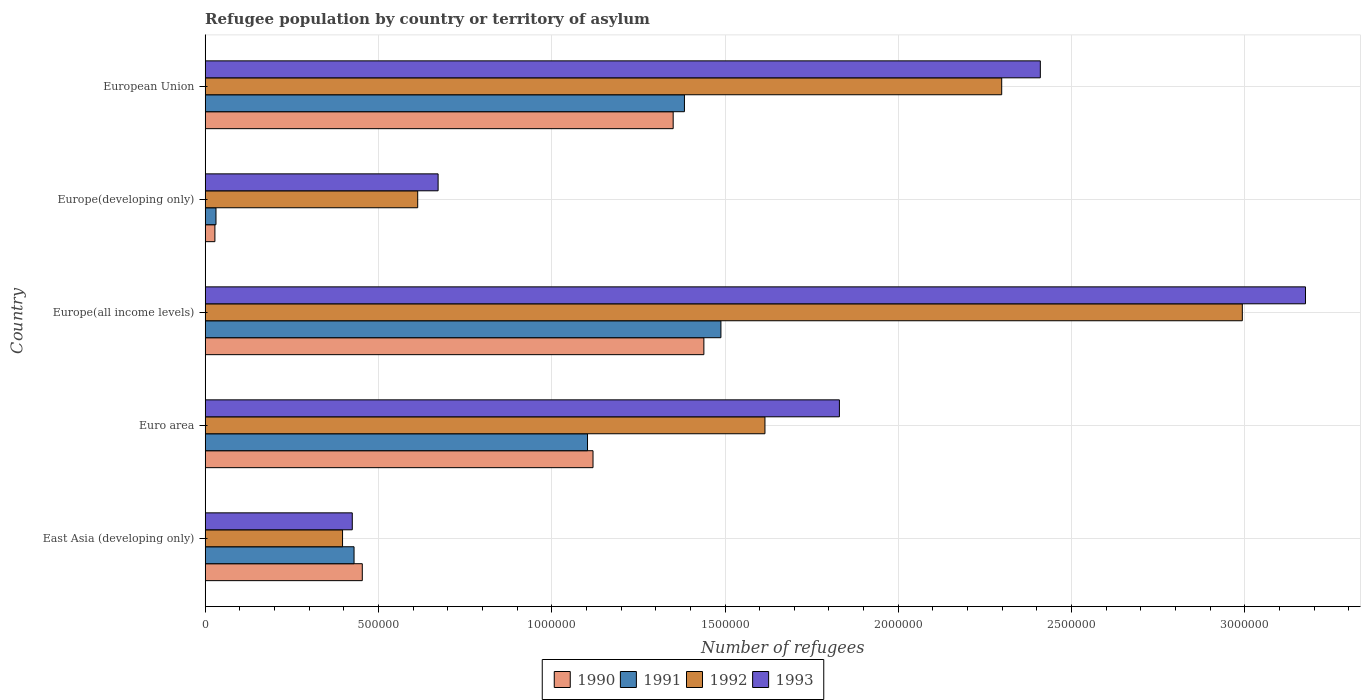How many different coloured bars are there?
Provide a short and direct response. 4. Are the number of bars per tick equal to the number of legend labels?
Provide a succinct answer. Yes. How many bars are there on the 5th tick from the top?
Give a very brief answer. 4. How many bars are there on the 5th tick from the bottom?
Your answer should be very brief. 4. What is the label of the 4th group of bars from the top?
Provide a succinct answer. Euro area. In how many cases, is the number of bars for a given country not equal to the number of legend labels?
Make the answer very short. 0. What is the number of refugees in 1993 in Europe(all income levels)?
Give a very brief answer. 3.18e+06. Across all countries, what is the maximum number of refugees in 1992?
Provide a short and direct response. 2.99e+06. Across all countries, what is the minimum number of refugees in 1990?
Provide a short and direct response. 2.80e+04. In which country was the number of refugees in 1992 maximum?
Your answer should be very brief. Europe(all income levels). In which country was the number of refugees in 1992 minimum?
Your answer should be compact. East Asia (developing only). What is the total number of refugees in 1992 in the graph?
Give a very brief answer. 7.92e+06. What is the difference between the number of refugees in 1991 in Europe(developing only) and that in European Union?
Your response must be concise. -1.35e+06. What is the difference between the number of refugees in 1990 in Europe(developing only) and the number of refugees in 1991 in European Union?
Make the answer very short. -1.35e+06. What is the average number of refugees in 1990 per country?
Your answer should be compact. 8.78e+05. What is the difference between the number of refugees in 1991 and number of refugees in 1990 in Europe(developing only)?
Your response must be concise. 3113. In how many countries, is the number of refugees in 1991 greater than 2700000 ?
Your response must be concise. 0. What is the ratio of the number of refugees in 1992 in Euro area to that in Europe(developing only)?
Provide a short and direct response. 2.63. What is the difference between the highest and the second highest number of refugees in 1991?
Your answer should be very brief. 1.05e+05. What is the difference between the highest and the lowest number of refugees in 1992?
Provide a short and direct response. 2.60e+06. Is the sum of the number of refugees in 1993 in East Asia (developing only) and Euro area greater than the maximum number of refugees in 1991 across all countries?
Make the answer very short. Yes. What does the 4th bar from the top in Euro area represents?
Provide a short and direct response. 1990. What does the 1st bar from the bottom in Euro area represents?
Make the answer very short. 1990. Is it the case that in every country, the sum of the number of refugees in 1993 and number of refugees in 1992 is greater than the number of refugees in 1991?
Your answer should be compact. Yes. Does the graph contain grids?
Provide a short and direct response. Yes. What is the title of the graph?
Make the answer very short. Refugee population by country or territory of asylum. Does "1962" appear as one of the legend labels in the graph?
Give a very brief answer. No. What is the label or title of the X-axis?
Give a very brief answer. Number of refugees. What is the Number of refugees in 1990 in East Asia (developing only)?
Provide a succinct answer. 4.53e+05. What is the Number of refugees of 1991 in East Asia (developing only)?
Offer a terse response. 4.30e+05. What is the Number of refugees of 1992 in East Asia (developing only)?
Make the answer very short. 3.96e+05. What is the Number of refugees in 1993 in East Asia (developing only)?
Offer a very short reply. 4.24e+05. What is the Number of refugees of 1990 in Euro area?
Provide a succinct answer. 1.12e+06. What is the Number of refugees of 1991 in Euro area?
Your answer should be very brief. 1.10e+06. What is the Number of refugees in 1992 in Euro area?
Provide a succinct answer. 1.62e+06. What is the Number of refugees of 1993 in Euro area?
Offer a terse response. 1.83e+06. What is the Number of refugees of 1990 in Europe(all income levels)?
Offer a terse response. 1.44e+06. What is the Number of refugees of 1991 in Europe(all income levels)?
Ensure brevity in your answer.  1.49e+06. What is the Number of refugees of 1992 in Europe(all income levels)?
Make the answer very short. 2.99e+06. What is the Number of refugees in 1993 in Europe(all income levels)?
Your answer should be very brief. 3.18e+06. What is the Number of refugees of 1990 in Europe(developing only)?
Your response must be concise. 2.80e+04. What is the Number of refugees of 1991 in Europe(developing only)?
Your answer should be very brief. 3.11e+04. What is the Number of refugees of 1992 in Europe(developing only)?
Offer a terse response. 6.13e+05. What is the Number of refugees in 1993 in Europe(developing only)?
Offer a very short reply. 6.72e+05. What is the Number of refugees of 1990 in European Union?
Provide a succinct answer. 1.35e+06. What is the Number of refugees of 1991 in European Union?
Offer a very short reply. 1.38e+06. What is the Number of refugees of 1992 in European Union?
Offer a terse response. 2.30e+06. What is the Number of refugees in 1993 in European Union?
Your answer should be very brief. 2.41e+06. Across all countries, what is the maximum Number of refugees in 1990?
Offer a terse response. 1.44e+06. Across all countries, what is the maximum Number of refugees in 1991?
Your answer should be compact. 1.49e+06. Across all countries, what is the maximum Number of refugees in 1992?
Make the answer very short. 2.99e+06. Across all countries, what is the maximum Number of refugees in 1993?
Your answer should be very brief. 3.18e+06. Across all countries, what is the minimum Number of refugees in 1990?
Provide a succinct answer. 2.80e+04. Across all countries, what is the minimum Number of refugees of 1991?
Your response must be concise. 3.11e+04. Across all countries, what is the minimum Number of refugees in 1992?
Make the answer very short. 3.96e+05. Across all countries, what is the minimum Number of refugees in 1993?
Ensure brevity in your answer.  4.24e+05. What is the total Number of refugees in 1990 in the graph?
Keep it short and to the point. 4.39e+06. What is the total Number of refugees in 1991 in the graph?
Ensure brevity in your answer.  4.44e+06. What is the total Number of refugees in 1992 in the graph?
Offer a terse response. 7.92e+06. What is the total Number of refugees of 1993 in the graph?
Your response must be concise. 8.51e+06. What is the difference between the Number of refugees of 1990 in East Asia (developing only) and that in Euro area?
Keep it short and to the point. -6.66e+05. What is the difference between the Number of refugees in 1991 in East Asia (developing only) and that in Euro area?
Provide a succinct answer. -6.74e+05. What is the difference between the Number of refugees of 1992 in East Asia (developing only) and that in Euro area?
Offer a terse response. -1.22e+06. What is the difference between the Number of refugees in 1993 in East Asia (developing only) and that in Euro area?
Your response must be concise. -1.41e+06. What is the difference between the Number of refugees of 1990 in East Asia (developing only) and that in Europe(all income levels)?
Your answer should be compact. -9.86e+05. What is the difference between the Number of refugees in 1991 in East Asia (developing only) and that in Europe(all income levels)?
Ensure brevity in your answer.  -1.06e+06. What is the difference between the Number of refugees in 1992 in East Asia (developing only) and that in Europe(all income levels)?
Provide a short and direct response. -2.60e+06. What is the difference between the Number of refugees in 1993 in East Asia (developing only) and that in Europe(all income levels)?
Ensure brevity in your answer.  -2.75e+06. What is the difference between the Number of refugees of 1990 in East Asia (developing only) and that in Europe(developing only)?
Offer a terse response. 4.25e+05. What is the difference between the Number of refugees in 1991 in East Asia (developing only) and that in Europe(developing only)?
Provide a succinct answer. 3.98e+05. What is the difference between the Number of refugees of 1992 in East Asia (developing only) and that in Europe(developing only)?
Your answer should be very brief. -2.17e+05. What is the difference between the Number of refugees in 1993 in East Asia (developing only) and that in Europe(developing only)?
Your response must be concise. -2.48e+05. What is the difference between the Number of refugees of 1990 in East Asia (developing only) and that in European Union?
Your response must be concise. -8.97e+05. What is the difference between the Number of refugees in 1991 in East Asia (developing only) and that in European Union?
Keep it short and to the point. -9.53e+05. What is the difference between the Number of refugees of 1992 in East Asia (developing only) and that in European Union?
Provide a succinct answer. -1.90e+06. What is the difference between the Number of refugees of 1993 in East Asia (developing only) and that in European Union?
Ensure brevity in your answer.  -1.99e+06. What is the difference between the Number of refugees of 1990 in Euro area and that in Europe(all income levels)?
Provide a short and direct response. -3.20e+05. What is the difference between the Number of refugees in 1991 in Euro area and that in Europe(all income levels)?
Provide a succinct answer. -3.85e+05. What is the difference between the Number of refugees of 1992 in Euro area and that in Europe(all income levels)?
Your answer should be very brief. -1.38e+06. What is the difference between the Number of refugees of 1993 in Euro area and that in Europe(all income levels)?
Offer a terse response. -1.34e+06. What is the difference between the Number of refugees in 1990 in Euro area and that in Europe(developing only)?
Your answer should be compact. 1.09e+06. What is the difference between the Number of refugees in 1991 in Euro area and that in Europe(developing only)?
Make the answer very short. 1.07e+06. What is the difference between the Number of refugees in 1992 in Euro area and that in Europe(developing only)?
Your answer should be compact. 1.00e+06. What is the difference between the Number of refugees of 1993 in Euro area and that in Europe(developing only)?
Make the answer very short. 1.16e+06. What is the difference between the Number of refugees in 1990 in Euro area and that in European Union?
Offer a terse response. -2.31e+05. What is the difference between the Number of refugees of 1991 in Euro area and that in European Union?
Make the answer very short. -2.80e+05. What is the difference between the Number of refugees of 1992 in Euro area and that in European Union?
Ensure brevity in your answer.  -6.83e+05. What is the difference between the Number of refugees of 1993 in Euro area and that in European Union?
Your answer should be very brief. -5.80e+05. What is the difference between the Number of refugees of 1990 in Europe(all income levels) and that in Europe(developing only)?
Give a very brief answer. 1.41e+06. What is the difference between the Number of refugees of 1991 in Europe(all income levels) and that in Europe(developing only)?
Offer a very short reply. 1.46e+06. What is the difference between the Number of refugees in 1992 in Europe(all income levels) and that in Europe(developing only)?
Give a very brief answer. 2.38e+06. What is the difference between the Number of refugees of 1993 in Europe(all income levels) and that in Europe(developing only)?
Provide a short and direct response. 2.50e+06. What is the difference between the Number of refugees in 1990 in Europe(all income levels) and that in European Union?
Keep it short and to the point. 8.86e+04. What is the difference between the Number of refugees in 1991 in Europe(all income levels) and that in European Union?
Keep it short and to the point. 1.05e+05. What is the difference between the Number of refugees in 1992 in Europe(all income levels) and that in European Union?
Your answer should be compact. 6.94e+05. What is the difference between the Number of refugees of 1993 in Europe(all income levels) and that in European Union?
Provide a short and direct response. 7.65e+05. What is the difference between the Number of refugees in 1990 in Europe(developing only) and that in European Union?
Your answer should be compact. -1.32e+06. What is the difference between the Number of refugees of 1991 in Europe(developing only) and that in European Union?
Provide a short and direct response. -1.35e+06. What is the difference between the Number of refugees in 1992 in Europe(developing only) and that in European Union?
Give a very brief answer. -1.69e+06. What is the difference between the Number of refugees in 1993 in Europe(developing only) and that in European Union?
Keep it short and to the point. -1.74e+06. What is the difference between the Number of refugees in 1990 in East Asia (developing only) and the Number of refugees in 1991 in Euro area?
Your answer should be very brief. -6.50e+05. What is the difference between the Number of refugees in 1990 in East Asia (developing only) and the Number of refugees in 1992 in Euro area?
Your response must be concise. -1.16e+06. What is the difference between the Number of refugees in 1990 in East Asia (developing only) and the Number of refugees in 1993 in Euro area?
Provide a short and direct response. -1.38e+06. What is the difference between the Number of refugees in 1991 in East Asia (developing only) and the Number of refugees in 1992 in Euro area?
Your answer should be compact. -1.19e+06. What is the difference between the Number of refugees of 1991 in East Asia (developing only) and the Number of refugees of 1993 in Euro area?
Ensure brevity in your answer.  -1.40e+06. What is the difference between the Number of refugees of 1992 in East Asia (developing only) and the Number of refugees of 1993 in Euro area?
Give a very brief answer. -1.43e+06. What is the difference between the Number of refugees of 1990 in East Asia (developing only) and the Number of refugees of 1991 in Europe(all income levels)?
Offer a terse response. -1.03e+06. What is the difference between the Number of refugees in 1990 in East Asia (developing only) and the Number of refugees in 1992 in Europe(all income levels)?
Provide a succinct answer. -2.54e+06. What is the difference between the Number of refugees of 1990 in East Asia (developing only) and the Number of refugees of 1993 in Europe(all income levels)?
Ensure brevity in your answer.  -2.72e+06. What is the difference between the Number of refugees of 1991 in East Asia (developing only) and the Number of refugees of 1992 in Europe(all income levels)?
Give a very brief answer. -2.56e+06. What is the difference between the Number of refugees in 1991 in East Asia (developing only) and the Number of refugees in 1993 in Europe(all income levels)?
Your answer should be compact. -2.75e+06. What is the difference between the Number of refugees in 1992 in East Asia (developing only) and the Number of refugees in 1993 in Europe(all income levels)?
Ensure brevity in your answer.  -2.78e+06. What is the difference between the Number of refugees of 1990 in East Asia (developing only) and the Number of refugees of 1991 in Europe(developing only)?
Provide a succinct answer. 4.22e+05. What is the difference between the Number of refugees in 1990 in East Asia (developing only) and the Number of refugees in 1992 in Europe(developing only)?
Give a very brief answer. -1.60e+05. What is the difference between the Number of refugees of 1990 in East Asia (developing only) and the Number of refugees of 1993 in Europe(developing only)?
Ensure brevity in your answer.  -2.19e+05. What is the difference between the Number of refugees of 1991 in East Asia (developing only) and the Number of refugees of 1992 in Europe(developing only)?
Give a very brief answer. -1.84e+05. What is the difference between the Number of refugees in 1991 in East Asia (developing only) and the Number of refugees in 1993 in Europe(developing only)?
Offer a terse response. -2.43e+05. What is the difference between the Number of refugees in 1992 in East Asia (developing only) and the Number of refugees in 1993 in Europe(developing only)?
Provide a short and direct response. -2.76e+05. What is the difference between the Number of refugees in 1990 in East Asia (developing only) and the Number of refugees in 1991 in European Union?
Your answer should be compact. -9.30e+05. What is the difference between the Number of refugees in 1990 in East Asia (developing only) and the Number of refugees in 1992 in European Union?
Provide a succinct answer. -1.85e+06. What is the difference between the Number of refugees of 1990 in East Asia (developing only) and the Number of refugees of 1993 in European Union?
Your answer should be very brief. -1.96e+06. What is the difference between the Number of refugees in 1991 in East Asia (developing only) and the Number of refugees in 1992 in European Union?
Keep it short and to the point. -1.87e+06. What is the difference between the Number of refugees of 1991 in East Asia (developing only) and the Number of refugees of 1993 in European Union?
Offer a very short reply. -1.98e+06. What is the difference between the Number of refugees in 1992 in East Asia (developing only) and the Number of refugees in 1993 in European Union?
Provide a succinct answer. -2.01e+06. What is the difference between the Number of refugees of 1990 in Euro area and the Number of refugees of 1991 in Europe(all income levels)?
Your answer should be very brief. -3.69e+05. What is the difference between the Number of refugees of 1990 in Euro area and the Number of refugees of 1992 in Europe(all income levels)?
Provide a short and direct response. -1.87e+06. What is the difference between the Number of refugees in 1990 in Euro area and the Number of refugees in 1993 in Europe(all income levels)?
Make the answer very short. -2.06e+06. What is the difference between the Number of refugees of 1991 in Euro area and the Number of refugees of 1992 in Europe(all income levels)?
Provide a short and direct response. -1.89e+06. What is the difference between the Number of refugees in 1991 in Euro area and the Number of refugees in 1993 in Europe(all income levels)?
Provide a succinct answer. -2.07e+06. What is the difference between the Number of refugees in 1992 in Euro area and the Number of refugees in 1993 in Europe(all income levels)?
Your response must be concise. -1.56e+06. What is the difference between the Number of refugees of 1990 in Euro area and the Number of refugees of 1991 in Europe(developing only)?
Give a very brief answer. 1.09e+06. What is the difference between the Number of refugees in 1990 in Euro area and the Number of refugees in 1992 in Europe(developing only)?
Offer a very short reply. 5.06e+05. What is the difference between the Number of refugees in 1990 in Euro area and the Number of refugees in 1993 in Europe(developing only)?
Make the answer very short. 4.47e+05. What is the difference between the Number of refugees in 1991 in Euro area and the Number of refugees in 1992 in Europe(developing only)?
Provide a succinct answer. 4.90e+05. What is the difference between the Number of refugees of 1991 in Euro area and the Number of refugees of 1993 in Europe(developing only)?
Make the answer very short. 4.31e+05. What is the difference between the Number of refugees of 1992 in Euro area and the Number of refugees of 1993 in Europe(developing only)?
Offer a terse response. 9.43e+05. What is the difference between the Number of refugees in 1990 in Euro area and the Number of refugees in 1991 in European Union?
Offer a terse response. -2.64e+05. What is the difference between the Number of refugees in 1990 in Euro area and the Number of refugees in 1992 in European Union?
Make the answer very short. -1.18e+06. What is the difference between the Number of refugees of 1990 in Euro area and the Number of refugees of 1993 in European Union?
Your answer should be compact. -1.29e+06. What is the difference between the Number of refugees in 1991 in Euro area and the Number of refugees in 1992 in European Union?
Keep it short and to the point. -1.20e+06. What is the difference between the Number of refugees in 1991 in Euro area and the Number of refugees in 1993 in European Union?
Your response must be concise. -1.31e+06. What is the difference between the Number of refugees of 1992 in Euro area and the Number of refugees of 1993 in European Union?
Offer a terse response. -7.95e+05. What is the difference between the Number of refugees of 1990 in Europe(all income levels) and the Number of refugees of 1991 in Europe(developing only)?
Offer a terse response. 1.41e+06. What is the difference between the Number of refugees in 1990 in Europe(all income levels) and the Number of refugees in 1992 in Europe(developing only)?
Keep it short and to the point. 8.26e+05. What is the difference between the Number of refugees of 1990 in Europe(all income levels) and the Number of refugees of 1993 in Europe(developing only)?
Your answer should be compact. 7.67e+05. What is the difference between the Number of refugees of 1991 in Europe(all income levels) and the Number of refugees of 1992 in Europe(developing only)?
Give a very brief answer. 8.75e+05. What is the difference between the Number of refugees in 1991 in Europe(all income levels) and the Number of refugees in 1993 in Europe(developing only)?
Your answer should be very brief. 8.16e+05. What is the difference between the Number of refugees of 1992 in Europe(all income levels) and the Number of refugees of 1993 in Europe(developing only)?
Your answer should be compact. 2.32e+06. What is the difference between the Number of refugees in 1990 in Europe(all income levels) and the Number of refugees in 1991 in European Union?
Provide a short and direct response. 5.61e+04. What is the difference between the Number of refugees of 1990 in Europe(all income levels) and the Number of refugees of 1992 in European Union?
Offer a very short reply. -8.59e+05. What is the difference between the Number of refugees in 1990 in Europe(all income levels) and the Number of refugees in 1993 in European Union?
Your response must be concise. -9.71e+05. What is the difference between the Number of refugees in 1991 in Europe(all income levels) and the Number of refugees in 1992 in European Union?
Provide a short and direct response. -8.10e+05. What is the difference between the Number of refugees in 1991 in Europe(all income levels) and the Number of refugees in 1993 in European Union?
Offer a terse response. -9.22e+05. What is the difference between the Number of refugees of 1992 in Europe(all income levels) and the Number of refugees of 1993 in European Union?
Provide a short and direct response. 5.83e+05. What is the difference between the Number of refugees of 1990 in Europe(developing only) and the Number of refugees of 1991 in European Union?
Your answer should be compact. -1.35e+06. What is the difference between the Number of refugees in 1990 in Europe(developing only) and the Number of refugees in 1992 in European Union?
Keep it short and to the point. -2.27e+06. What is the difference between the Number of refugees of 1990 in Europe(developing only) and the Number of refugees of 1993 in European Union?
Give a very brief answer. -2.38e+06. What is the difference between the Number of refugees in 1991 in Europe(developing only) and the Number of refugees in 1992 in European Union?
Offer a very short reply. -2.27e+06. What is the difference between the Number of refugees of 1991 in Europe(developing only) and the Number of refugees of 1993 in European Union?
Offer a very short reply. -2.38e+06. What is the difference between the Number of refugees in 1992 in Europe(developing only) and the Number of refugees in 1993 in European Union?
Make the answer very short. -1.80e+06. What is the average Number of refugees of 1990 per country?
Ensure brevity in your answer.  8.78e+05. What is the average Number of refugees in 1991 per country?
Provide a short and direct response. 8.87e+05. What is the average Number of refugees of 1992 per country?
Provide a short and direct response. 1.58e+06. What is the average Number of refugees in 1993 per country?
Offer a very short reply. 1.70e+06. What is the difference between the Number of refugees of 1990 and Number of refugees of 1991 in East Asia (developing only)?
Provide a succinct answer. 2.38e+04. What is the difference between the Number of refugees of 1990 and Number of refugees of 1992 in East Asia (developing only)?
Provide a short and direct response. 5.70e+04. What is the difference between the Number of refugees of 1990 and Number of refugees of 1993 in East Asia (developing only)?
Keep it short and to the point. 2.89e+04. What is the difference between the Number of refugees of 1991 and Number of refugees of 1992 in East Asia (developing only)?
Offer a very short reply. 3.32e+04. What is the difference between the Number of refugees in 1991 and Number of refugees in 1993 in East Asia (developing only)?
Give a very brief answer. 5099. What is the difference between the Number of refugees of 1992 and Number of refugees of 1993 in East Asia (developing only)?
Ensure brevity in your answer.  -2.81e+04. What is the difference between the Number of refugees in 1990 and Number of refugees in 1991 in Euro area?
Provide a succinct answer. 1.58e+04. What is the difference between the Number of refugees in 1990 and Number of refugees in 1992 in Euro area?
Your answer should be compact. -4.96e+05. What is the difference between the Number of refugees of 1990 and Number of refugees of 1993 in Euro area?
Your answer should be compact. -7.11e+05. What is the difference between the Number of refugees of 1991 and Number of refugees of 1992 in Euro area?
Offer a terse response. -5.12e+05. What is the difference between the Number of refugees of 1991 and Number of refugees of 1993 in Euro area?
Give a very brief answer. -7.27e+05. What is the difference between the Number of refugees in 1992 and Number of refugees in 1993 in Euro area?
Provide a succinct answer. -2.15e+05. What is the difference between the Number of refugees in 1990 and Number of refugees in 1991 in Europe(all income levels)?
Keep it short and to the point. -4.92e+04. What is the difference between the Number of refugees of 1990 and Number of refugees of 1992 in Europe(all income levels)?
Offer a very short reply. -1.55e+06. What is the difference between the Number of refugees in 1990 and Number of refugees in 1993 in Europe(all income levels)?
Make the answer very short. -1.74e+06. What is the difference between the Number of refugees in 1991 and Number of refugees in 1992 in Europe(all income levels)?
Keep it short and to the point. -1.50e+06. What is the difference between the Number of refugees of 1991 and Number of refugees of 1993 in Europe(all income levels)?
Provide a succinct answer. -1.69e+06. What is the difference between the Number of refugees of 1992 and Number of refugees of 1993 in Europe(all income levels)?
Make the answer very short. -1.82e+05. What is the difference between the Number of refugees in 1990 and Number of refugees in 1991 in Europe(developing only)?
Your answer should be very brief. -3113. What is the difference between the Number of refugees in 1990 and Number of refugees in 1992 in Europe(developing only)?
Your answer should be very brief. -5.85e+05. What is the difference between the Number of refugees of 1990 and Number of refugees of 1993 in Europe(developing only)?
Your response must be concise. -6.44e+05. What is the difference between the Number of refugees of 1991 and Number of refugees of 1992 in Europe(developing only)?
Your response must be concise. -5.82e+05. What is the difference between the Number of refugees of 1991 and Number of refugees of 1993 in Europe(developing only)?
Provide a succinct answer. -6.41e+05. What is the difference between the Number of refugees of 1992 and Number of refugees of 1993 in Europe(developing only)?
Your answer should be very brief. -5.89e+04. What is the difference between the Number of refugees of 1990 and Number of refugees of 1991 in European Union?
Your answer should be very brief. -3.25e+04. What is the difference between the Number of refugees of 1990 and Number of refugees of 1992 in European Union?
Your answer should be very brief. -9.48e+05. What is the difference between the Number of refugees of 1990 and Number of refugees of 1993 in European Union?
Keep it short and to the point. -1.06e+06. What is the difference between the Number of refugees of 1991 and Number of refugees of 1992 in European Union?
Your response must be concise. -9.15e+05. What is the difference between the Number of refugees of 1991 and Number of refugees of 1993 in European Union?
Make the answer very short. -1.03e+06. What is the difference between the Number of refugees in 1992 and Number of refugees in 1993 in European Union?
Your answer should be very brief. -1.11e+05. What is the ratio of the Number of refugees of 1990 in East Asia (developing only) to that in Euro area?
Make the answer very short. 0.41. What is the ratio of the Number of refugees of 1991 in East Asia (developing only) to that in Euro area?
Offer a very short reply. 0.39. What is the ratio of the Number of refugees of 1992 in East Asia (developing only) to that in Euro area?
Make the answer very short. 0.25. What is the ratio of the Number of refugees of 1993 in East Asia (developing only) to that in Euro area?
Ensure brevity in your answer.  0.23. What is the ratio of the Number of refugees in 1990 in East Asia (developing only) to that in Europe(all income levels)?
Make the answer very short. 0.32. What is the ratio of the Number of refugees in 1991 in East Asia (developing only) to that in Europe(all income levels)?
Provide a succinct answer. 0.29. What is the ratio of the Number of refugees of 1992 in East Asia (developing only) to that in Europe(all income levels)?
Make the answer very short. 0.13. What is the ratio of the Number of refugees in 1993 in East Asia (developing only) to that in Europe(all income levels)?
Make the answer very short. 0.13. What is the ratio of the Number of refugees of 1990 in East Asia (developing only) to that in Europe(developing only)?
Make the answer very short. 16.19. What is the ratio of the Number of refugees in 1991 in East Asia (developing only) to that in Europe(developing only)?
Ensure brevity in your answer.  13.81. What is the ratio of the Number of refugees in 1992 in East Asia (developing only) to that in Europe(developing only)?
Provide a succinct answer. 0.65. What is the ratio of the Number of refugees in 1993 in East Asia (developing only) to that in Europe(developing only)?
Make the answer very short. 0.63. What is the ratio of the Number of refugees of 1990 in East Asia (developing only) to that in European Union?
Make the answer very short. 0.34. What is the ratio of the Number of refugees of 1991 in East Asia (developing only) to that in European Union?
Keep it short and to the point. 0.31. What is the ratio of the Number of refugees in 1992 in East Asia (developing only) to that in European Union?
Provide a succinct answer. 0.17. What is the ratio of the Number of refugees of 1993 in East Asia (developing only) to that in European Union?
Offer a very short reply. 0.18. What is the ratio of the Number of refugees of 1990 in Euro area to that in Europe(all income levels)?
Provide a succinct answer. 0.78. What is the ratio of the Number of refugees of 1991 in Euro area to that in Europe(all income levels)?
Offer a terse response. 0.74. What is the ratio of the Number of refugees of 1992 in Euro area to that in Europe(all income levels)?
Your answer should be compact. 0.54. What is the ratio of the Number of refugees of 1993 in Euro area to that in Europe(all income levels)?
Your answer should be compact. 0.58. What is the ratio of the Number of refugees in 1990 in Euro area to that in Europe(developing only)?
Give a very brief answer. 39.97. What is the ratio of the Number of refugees in 1991 in Euro area to that in Europe(developing only)?
Your response must be concise. 35.46. What is the ratio of the Number of refugees in 1992 in Euro area to that in Europe(developing only)?
Offer a very short reply. 2.63. What is the ratio of the Number of refugees of 1993 in Euro area to that in Europe(developing only)?
Provide a succinct answer. 2.72. What is the ratio of the Number of refugees in 1990 in Euro area to that in European Union?
Your answer should be very brief. 0.83. What is the ratio of the Number of refugees of 1991 in Euro area to that in European Union?
Give a very brief answer. 0.8. What is the ratio of the Number of refugees of 1992 in Euro area to that in European Union?
Your response must be concise. 0.7. What is the ratio of the Number of refugees of 1993 in Euro area to that in European Union?
Ensure brevity in your answer.  0.76. What is the ratio of the Number of refugees in 1990 in Europe(all income levels) to that in Europe(developing only)?
Ensure brevity in your answer.  51.39. What is the ratio of the Number of refugees in 1991 in Europe(all income levels) to that in Europe(developing only)?
Provide a short and direct response. 47.83. What is the ratio of the Number of refugees of 1992 in Europe(all income levels) to that in Europe(developing only)?
Make the answer very short. 4.88. What is the ratio of the Number of refugees in 1993 in Europe(all income levels) to that in Europe(developing only)?
Give a very brief answer. 4.72. What is the ratio of the Number of refugees in 1990 in Europe(all income levels) to that in European Union?
Your answer should be compact. 1.07. What is the ratio of the Number of refugees of 1991 in Europe(all income levels) to that in European Union?
Ensure brevity in your answer.  1.08. What is the ratio of the Number of refugees of 1992 in Europe(all income levels) to that in European Union?
Your response must be concise. 1.3. What is the ratio of the Number of refugees in 1993 in Europe(all income levels) to that in European Union?
Your response must be concise. 1.32. What is the ratio of the Number of refugees in 1990 in Europe(developing only) to that in European Union?
Provide a succinct answer. 0.02. What is the ratio of the Number of refugees of 1991 in Europe(developing only) to that in European Union?
Keep it short and to the point. 0.02. What is the ratio of the Number of refugees of 1992 in Europe(developing only) to that in European Union?
Provide a short and direct response. 0.27. What is the ratio of the Number of refugees in 1993 in Europe(developing only) to that in European Union?
Give a very brief answer. 0.28. What is the difference between the highest and the second highest Number of refugees in 1990?
Give a very brief answer. 8.86e+04. What is the difference between the highest and the second highest Number of refugees in 1991?
Your answer should be very brief. 1.05e+05. What is the difference between the highest and the second highest Number of refugees of 1992?
Offer a very short reply. 6.94e+05. What is the difference between the highest and the second highest Number of refugees in 1993?
Ensure brevity in your answer.  7.65e+05. What is the difference between the highest and the lowest Number of refugees of 1990?
Offer a very short reply. 1.41e+06. What is the difference between the highest and the lowest Number of refugees of 1991?
Make the answer very short. 1.46e+06. What is the difference between the highest and the lowest Number of refugees of 1992?
Offer a terse response. 2.60e+06. What is the difference between the highest and the lowest Number of refugees in 1993?
Provide a succinct answer. 2.75e+06. 